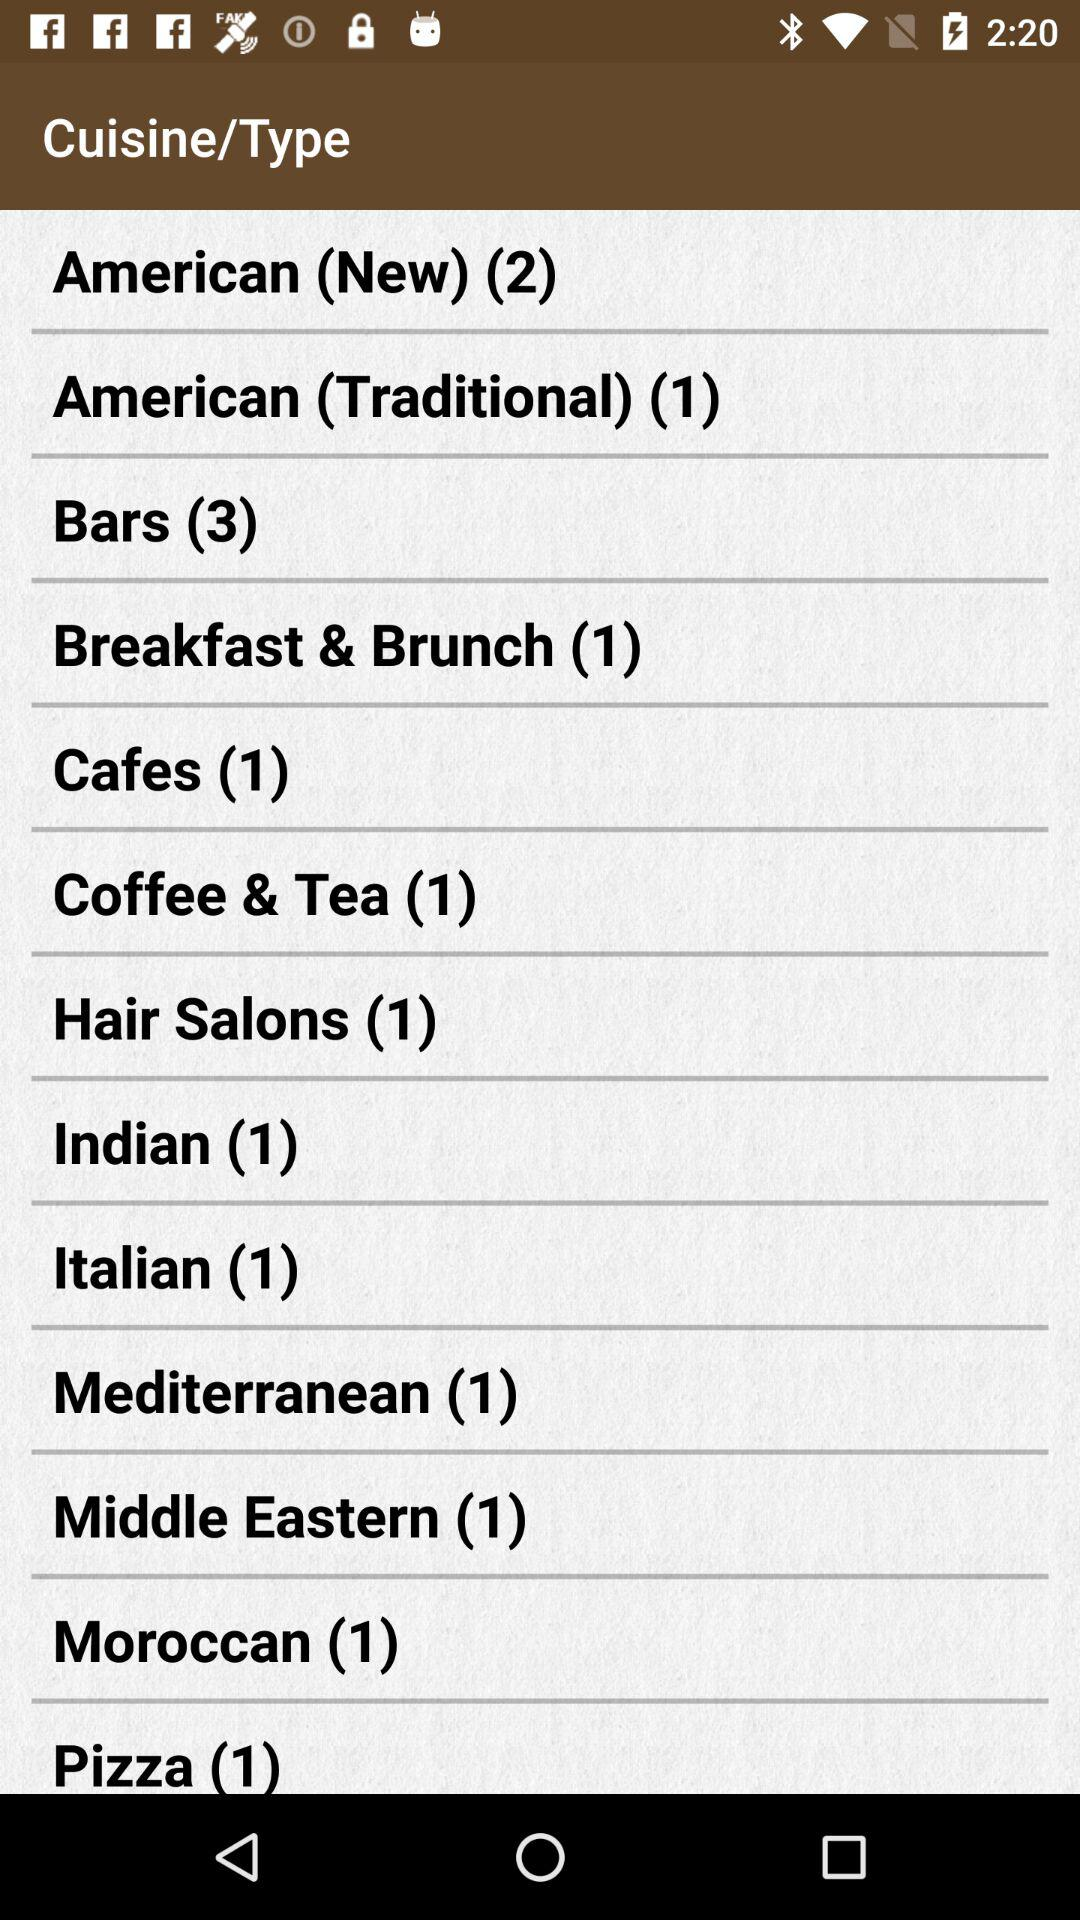What is the count of cuisine in "Bars"? The count is 3. 